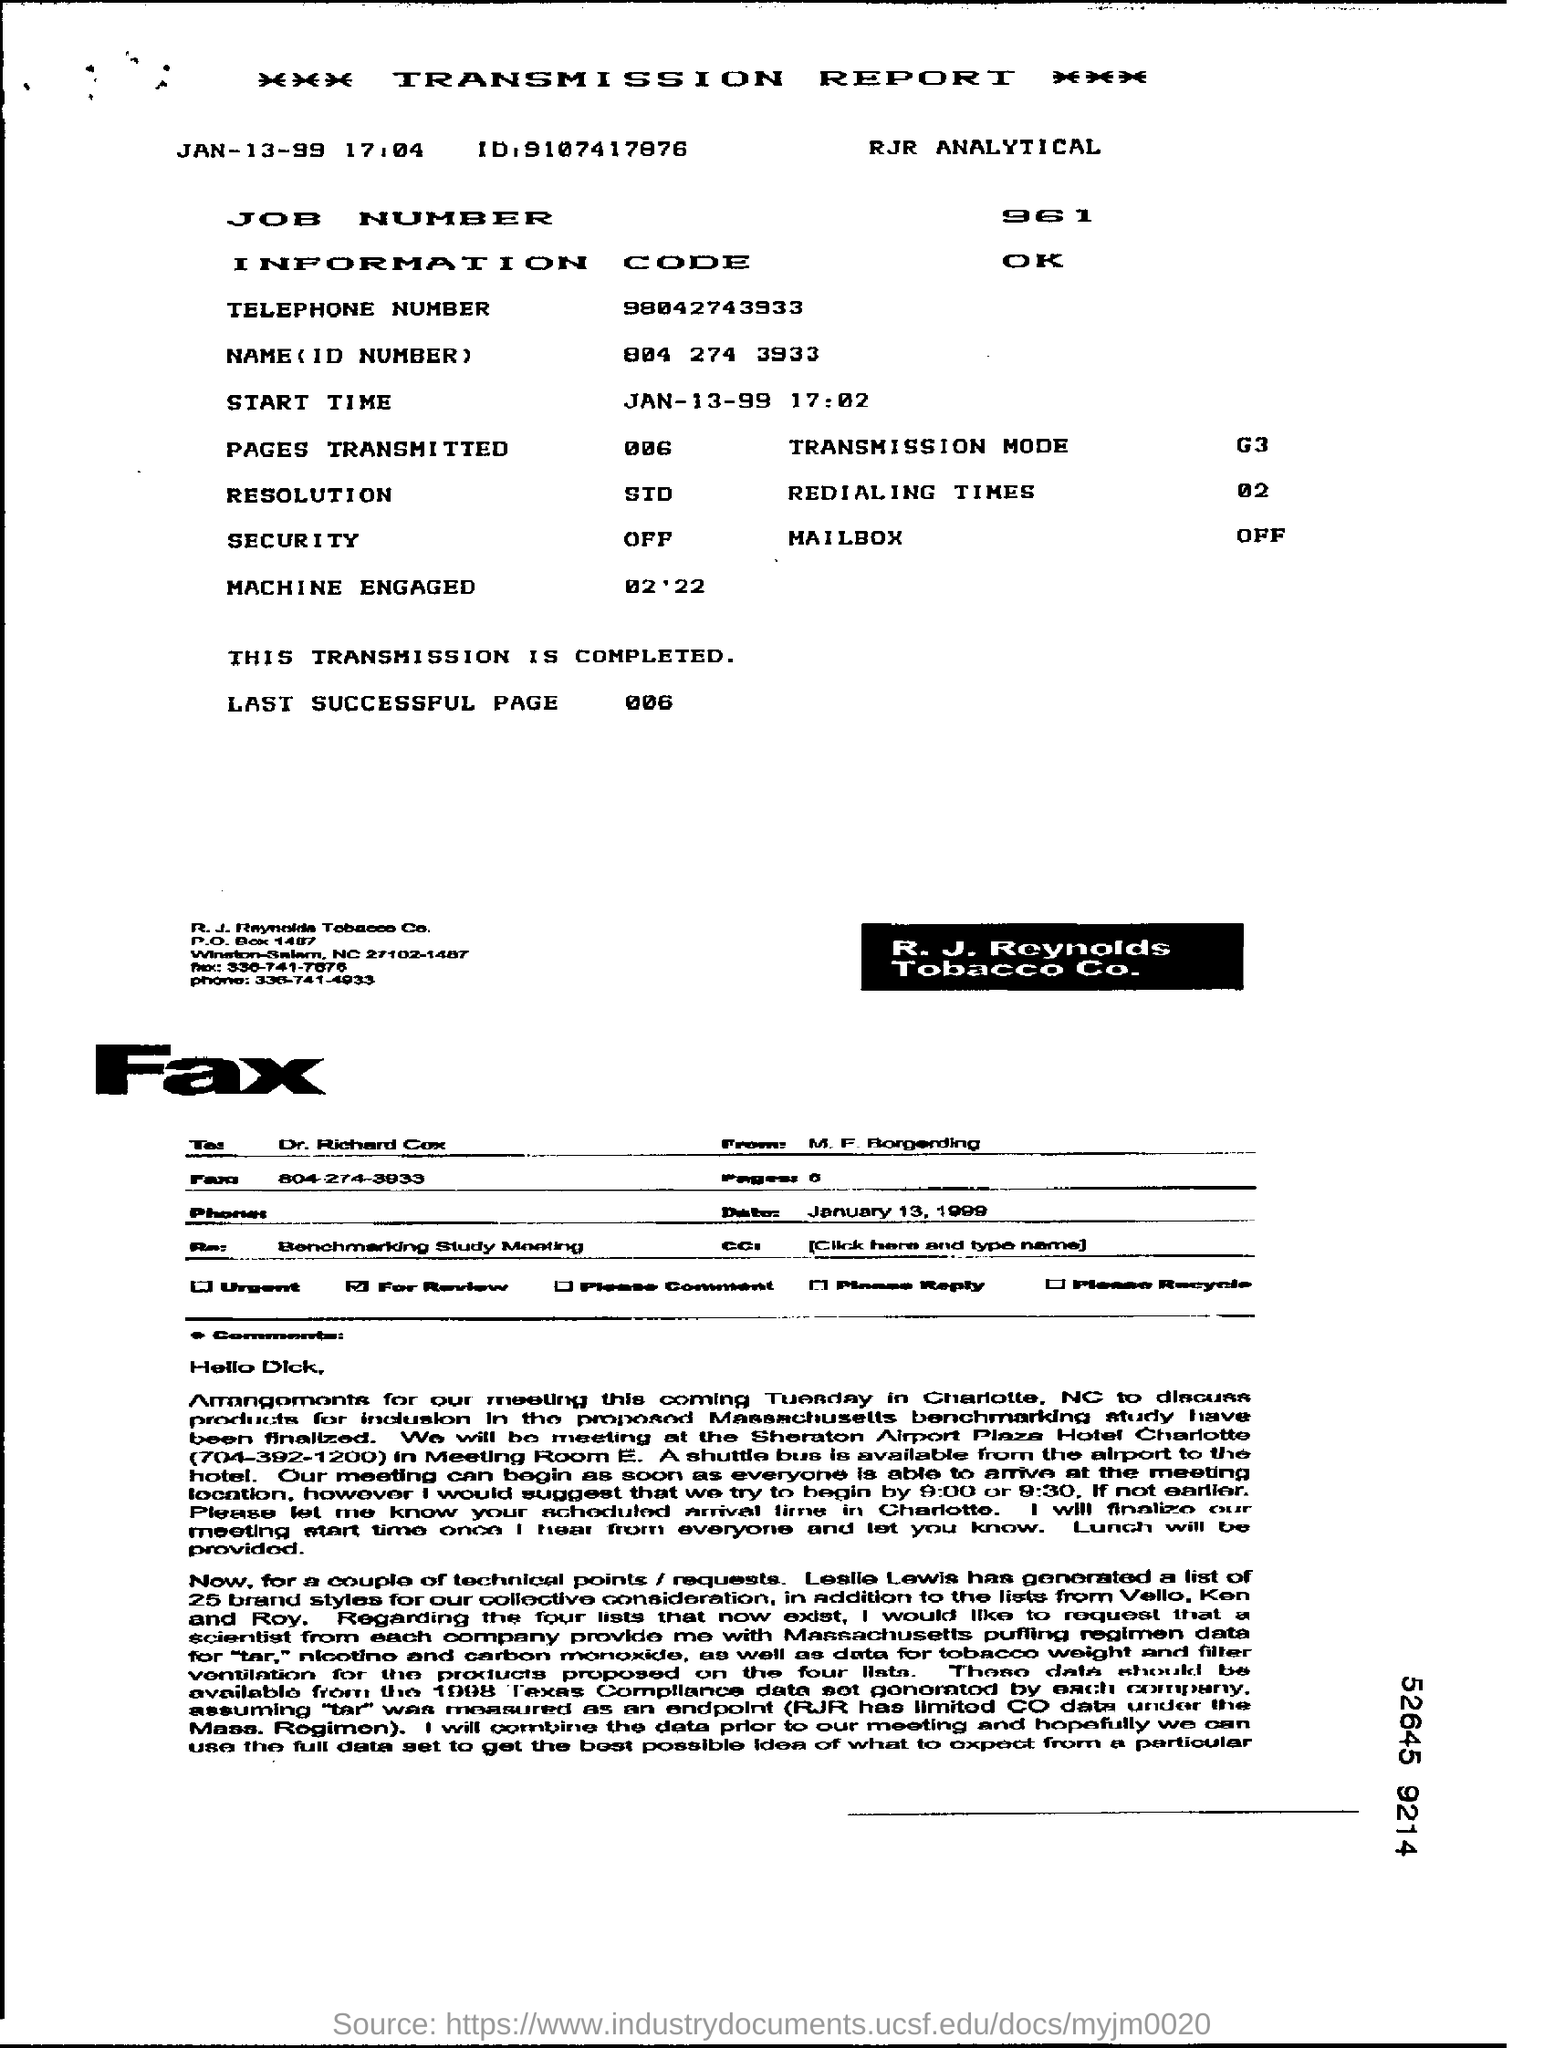Outline some significant characteristics in this image. The telephone number is 98042743933. The JOB number is 961. The Information Code is a.... The date mentioned at the top left of the document is January 13, 1999. The Transmission Mode Field contains information about the method by which data is transmitted in the corresponding LDAP message. In the example "G3..", the Transmission Mode Field indicates that the data is being transmitted in Groupwise Address Book (GAB) format. 